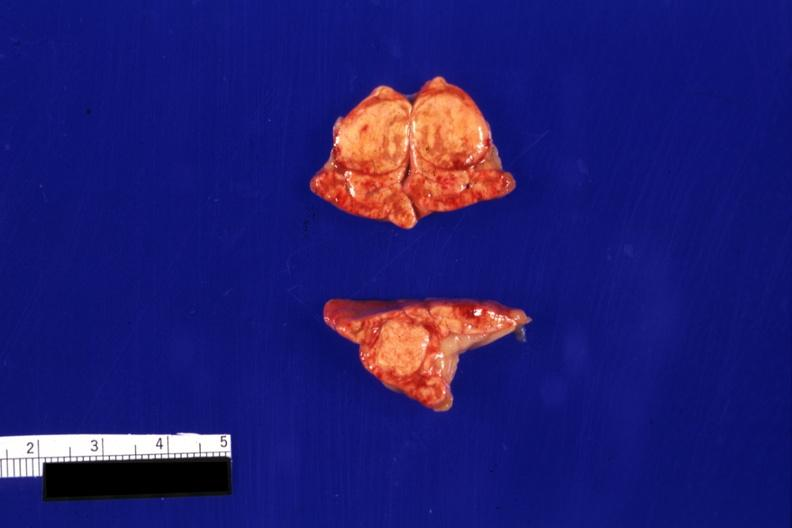s nodule present?
Answer the question using a single word or phrase. Yes 